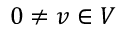Convert formula to latex. <formula><loc_0><loc_0><loc_500><loc_500>0 \not = v \in V</formula> 